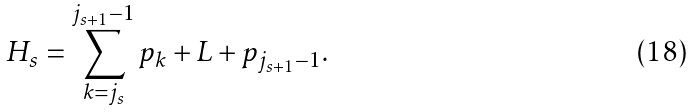<formula> <loc_0><loc_0><loc_500><loc_500>H _ { s } = \sum _ { k = j _ { s } } ^ { j _ { s + 1 } - 1 } p _ { k } + L + p _ { j _ { s + 1 } - 1 } .</formula> 